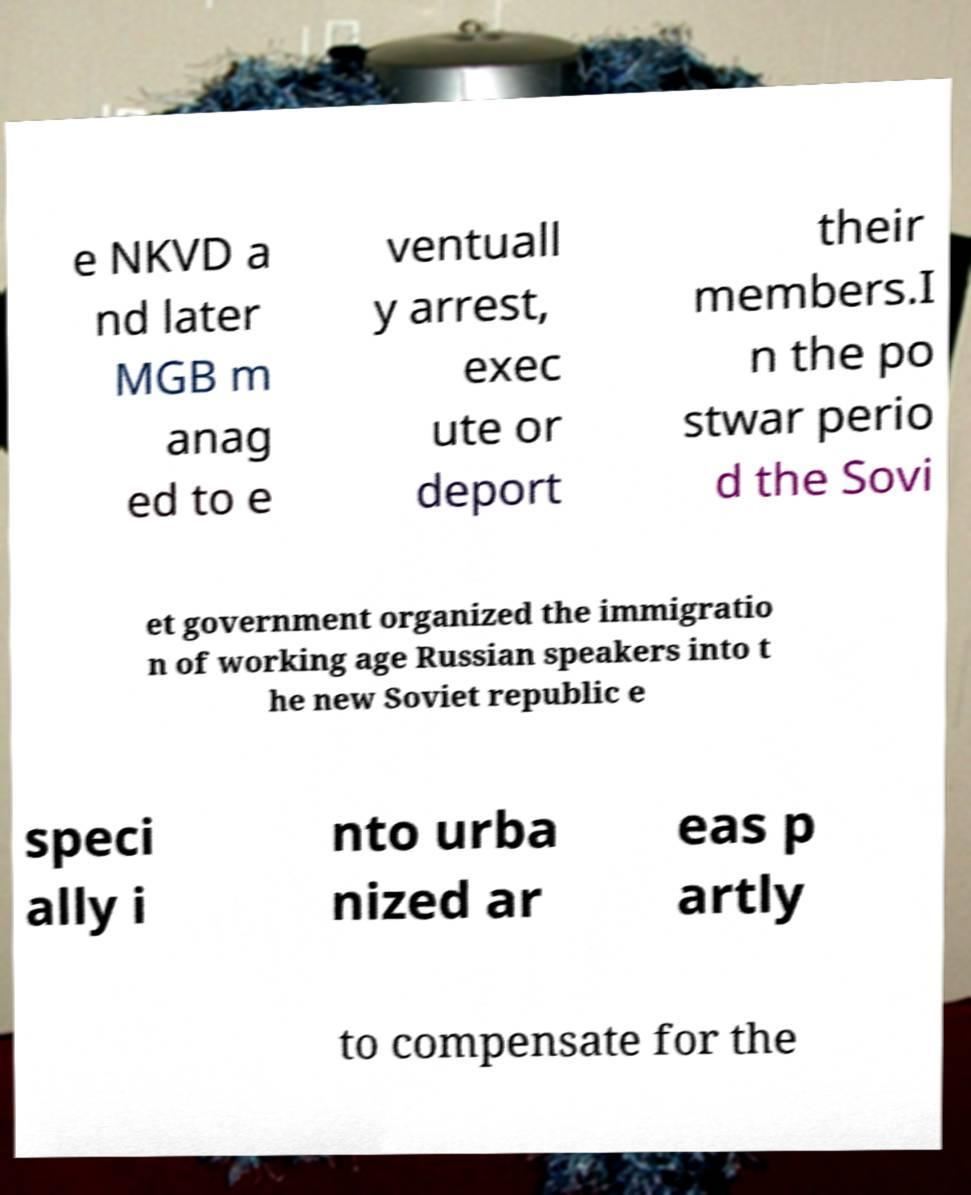Could you assist in decoding the text presented in this image and type it out clearly? e NKVD a nd later MGB m anag ed to e ventuall y arrest, exec ute or deport their members.I n the po stwar perio d the Sovi et government organized the immigratio n of working age Russian speakers into t he new Soviet republic e speci ally i nto urba nized ar eas p artly to compensate for the 